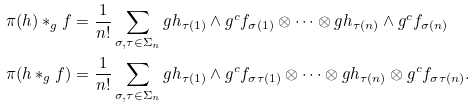<formula> <loc_0><loc_0><loc_500><loc_500>\pi ( h ) \ast _ { g } f & = \frac { 1 } { n ! } \sum _ { \sigma , \tau \in \Sigma _ { n } } g h _ { \tau ( 1 ) } \wedge g ^ { c } f _ { \sigma ( 1 ) } \otimes \cdots \otimes g h _ { \tau ( n ) } \wedge g ^ { c } f _ { \sigma ( n ) } \\ \pi ( h \ast _ { g } f ) & = \frac { 1 } { n ! } \sum _ { \sigma , \tau \in \Sigma _ { n } } g h _ { \tau ( 1 ) } \wedge g ^ { c } f _ { \sigma \tau ( 1 ) } \otimes \cdots \otimes g h _ { \tau ( n ) } \otimes g ^ { c } f _ { \sigma \tau ( n ) } .</formula> 